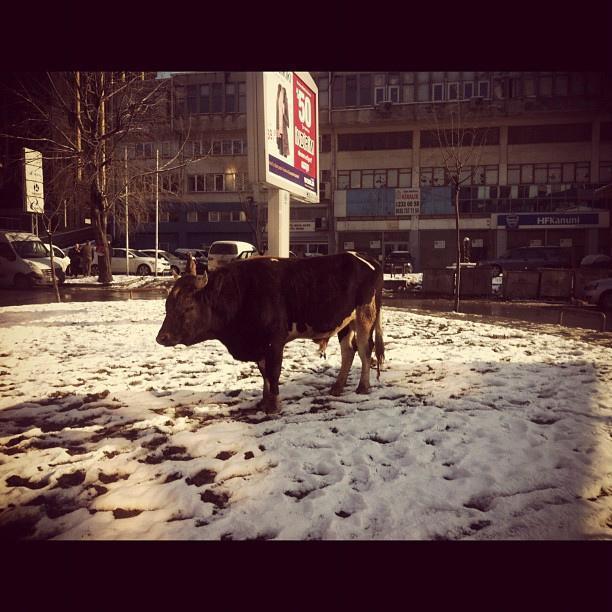How many skateboards do you see?
Give a very brief answer. 0. 